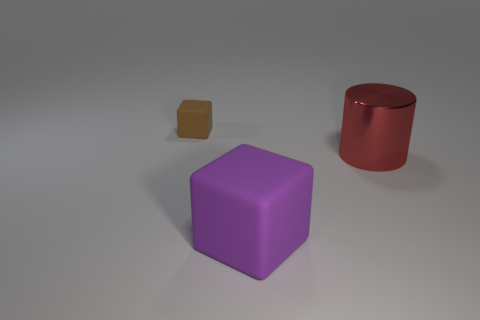Is there anything else that has the same size as the brown block?
Provide a short and direct response. No. There is a object that is made of the same material as the small cube; what size is it?
Your answer should be compact. Large. What number of objects are the same color as the big cube?
Keep it short and to the point. 0. Are there the same number of cubes that are in front of the tiny brown matte thing and large rubber blocks that are behind the red shiny cylinder?
Provide a succinct answer. No. Is there anything else that is the same material as the tiny object?
Offer a very short reply. Yes. There is a cube that is behind the big matte object; what color is it?
Make the answer very short. Brown. Is the number of large rubber objects in front of the large rubber block the same as the number of purple matte things?
Provide a succinct answer. No. How many other objects are there of the same shape as the big purple rubber object?
Offer a very short reply. 1. What number of small objects are behind the red cylinder?
Keep it short and to the point. 1. There is a thing that is both in front of the small brown block and to the left of the large red cylinder; how big is it?
Your answer should be very brief. Large. 